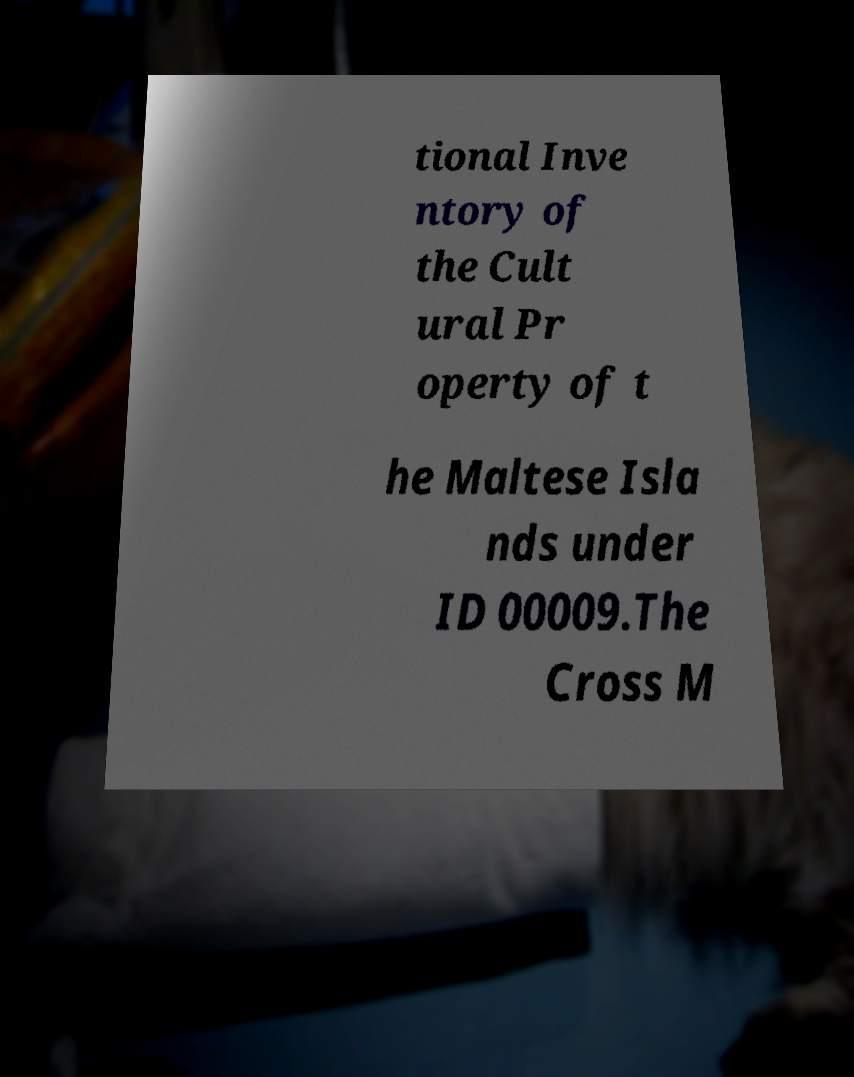What messages or text are displayed in this image? I need them in a readable, typed format. tional Inve ntory of the Cult ural Pr operty of t he Maltese Isla nds under ID 00009.The Cross M 